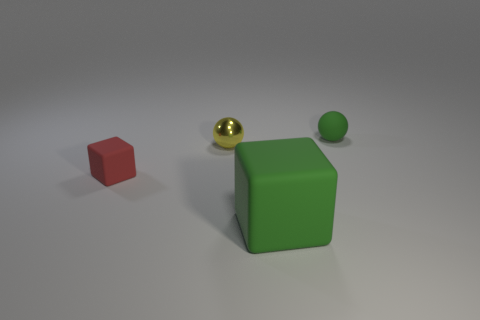There is a large green object that is the same shape as the tiny red rubber object; what is it made of?
Offer a very short reply. Rubber. What material is the red object that is left of the cube that is to the right of the tiny shiny thing?
Provide a short and direct response. Rubber. Does the red object have the same shape as the green thing behind the big matte block?
Provide a short and direct response. No. How many matte objects are either small yellow balls or big cyan cubes?
Offer a terse response. 0. There is a tiny sphere to the right of the sphere in front of the object that is behind the small metallic ball; what color is it?
Give a very brief answer. Green. What number of other things are there of the same material as the yellow thing
Offer a terse response. 0. There is a green object on the right side of the large green object; is it the same shape as the small red rubber object?
Offer a very short reply. No. How many small objects are either green blocks or cyan rubber things?
Your answer should be very brief. 0. Is the number of tiny rubber blocks in front of the tiny yellow shiny thing the same as the number of red blocks in front of the big matte thing?
Offer a terse response. No. What number of other objects are the same color as the tiny matte ball?
Keep it short and to the point. 1. 